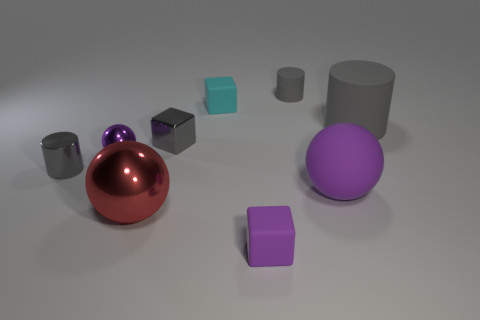There is a small gray thing that is the same shape as the small cyan rubber object; what is it made of?
Your response must be concise. Metal. What number of tiny cubes have the same color as the big cylinder?
Keep it short and to the point. 1. There is a purple sphere that is the same material as the big red ball; what size is it?
Make the answer very short. Small. What number of cyan things are either small matte objects or small shiny balls?
Your answer should be compact. 1. There is a purple sphere that is behind the big purple rubber sphere; how many matte blocks are behind it?
Offer a very short reply. 1. Is the number of things that are behind the purple matte block greater than the number of small metal blocks on the right side of the large gray thing?
Give a very brief answer. Yes. What is the big cylinder made of?
Keep it short and to the point. Rubber. Are there any gray metallic blocks of the same size as the rubber sphere?
Make the answer very short. No. There is a purple sphere that is the same size as the metal block; what is it made of?
Make the answer very short. Metal. How many big metallic things are there?
Provide a short and direct response. 1. 